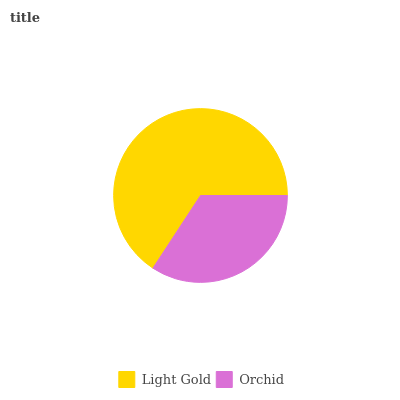Is Orchid the minimum?
Answer yes or no. Yes. Is Light Gold the maximum?
Answer yes or no. Yes. Is Orchid the maximum?
Answer yes or no. No. Is Light Gold greater than Orchid?
Answer yes or no. Yes. Is Orchid less than Light Gold?
Answer yes or no. Yes. Is Orchid greater than Light Gold?
Answer yes or no. No. Is Light Gold less than Orchid?
Answer yes or no. No. Is Light Gold the high median?
Answer yes or no. Yes. Is Orchid the low median?
Answer yes or no. Yes. Is Orchid the high median?
Answer yes or no. No. Is Light Gold the low median?
Answer yes or no. No. 